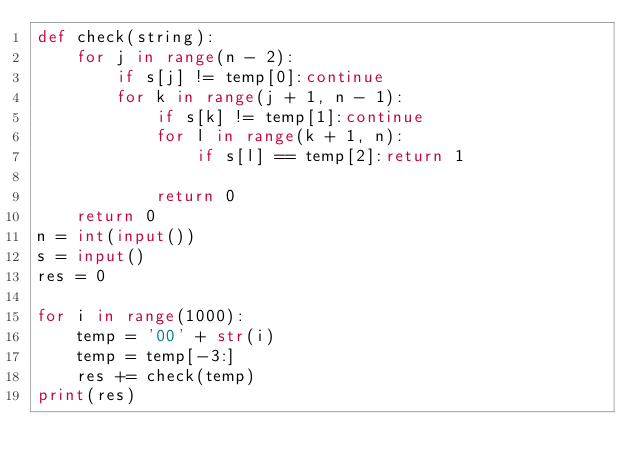Convert code to text. <code><loc_0><loc_0><loc_500><loc_500><_Python_>def check(string):
    for j in range(n - 2):
        if s[j] != temp[0]:continue 
        for k in range(j + 1, n - 1):
            if s[k] != temp[1]:continue 
            for l in range(k + 1, n):
                if s[l] == temp[2]:return 1
            
            return 0
    return 0
n = int(input())
s = input()
res = 0

for i in range(1000):
    temp = '00' + str(i)
    temp = temp[-3:]
    res += check(temp)
print(res)
    </code> 